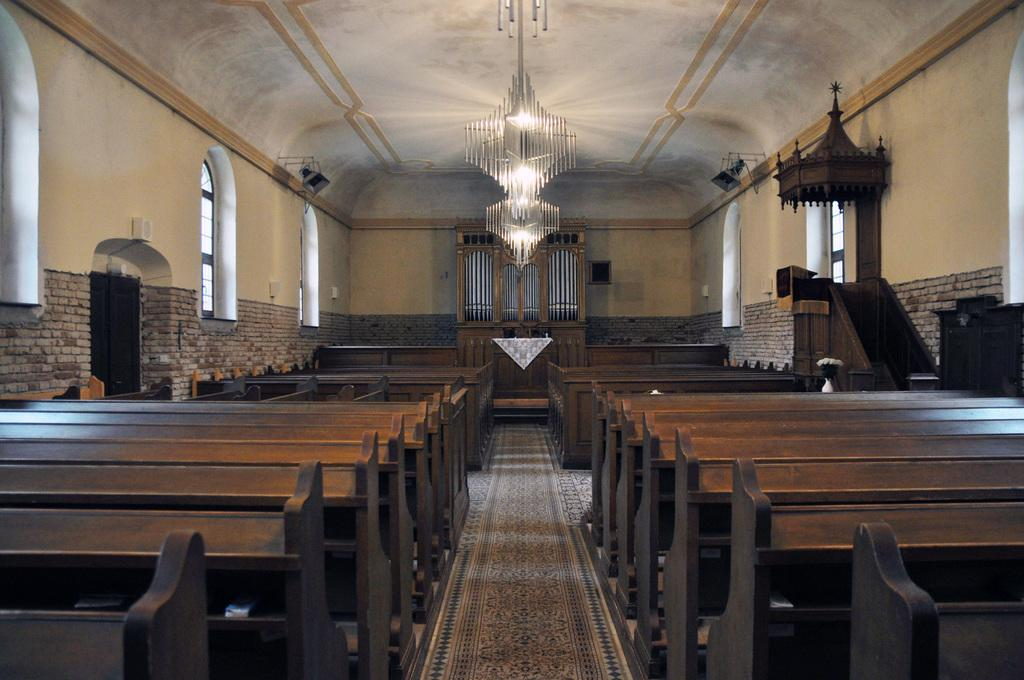What can be seen on both sides of the image? There are benches on the left and right sides of the image. What is on the floor in the middle of the image? There is a carpet on the floor in the middle of the image. What are some features of the room depicted in the image? There are doors, windows, lights, steps, and other objects in the image. What is the background of the image made of? There is a wall in the image. How does the beetle push the benches in the image? There is no beetle present in the image, so it cannot push the benches. What type of care is being provided to the objects in the image? The image does not depict any care being provided to the objects; it simply shows their placement and arrangement. 